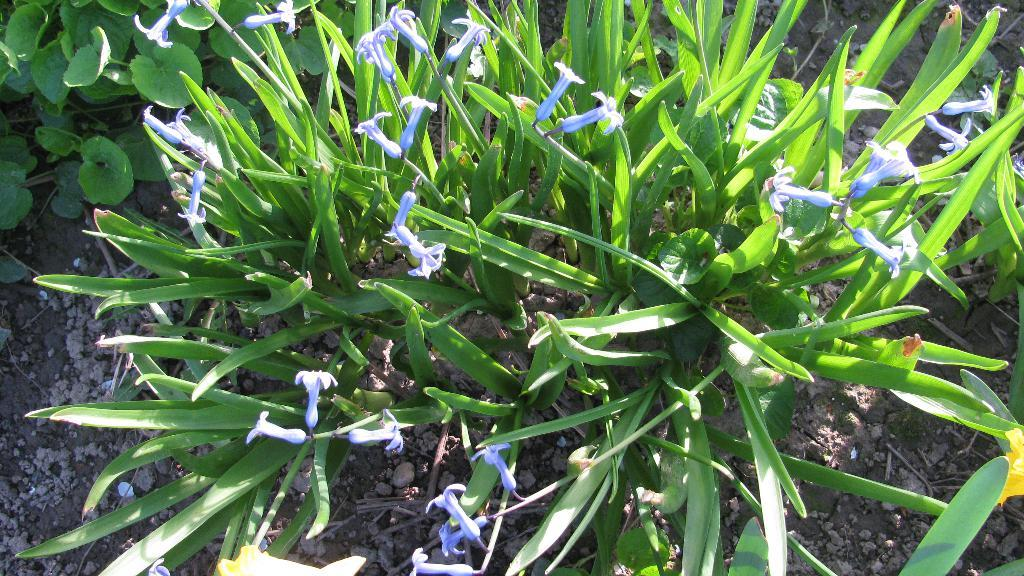What type of living organisms can be seen in the image? There are flowers and plants in the image. Can you describe the plants in the image? The plants in the image are not specified, but they are present alongside the flowers. Where is the library located in the image? There is no library present in the image; it features flowers and plants. What type of fowl can be seen in the image? There is no fowl present in the image; it features flowers and plants. 